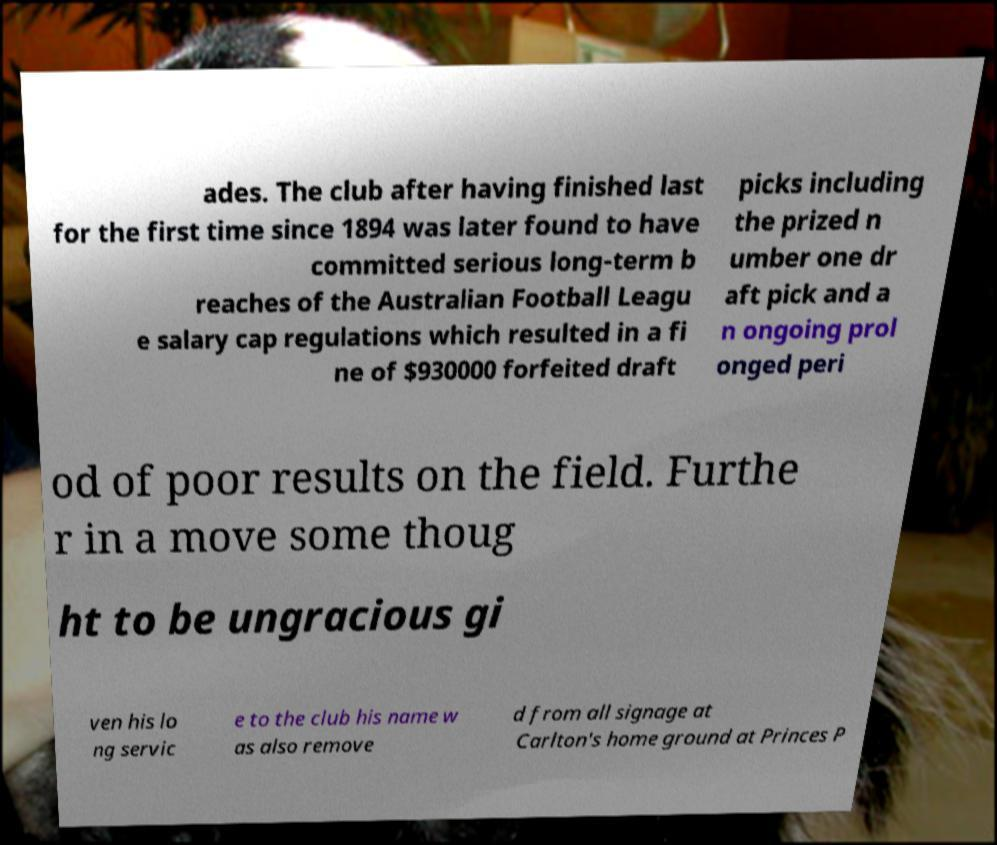There's text embedded in this image that I need extracted. Can you transcribe it verbatim? ades. The club after having finished last for the first time since 1894 was later found to have committed serious long-term b reaches of the Australian Football Leagu e salary cap regulations which resulted in a fi ne of $930000 forfeited draft picks including the prized n umber one dr aft pick and a n ongoing prol onged peri od of poor results on the field. Furthe r in a move some thoug ht to be ungracious gi ven his lo ng servic e to the club his name w as also remove d from all signage at Carlton's home ground at Princes P 